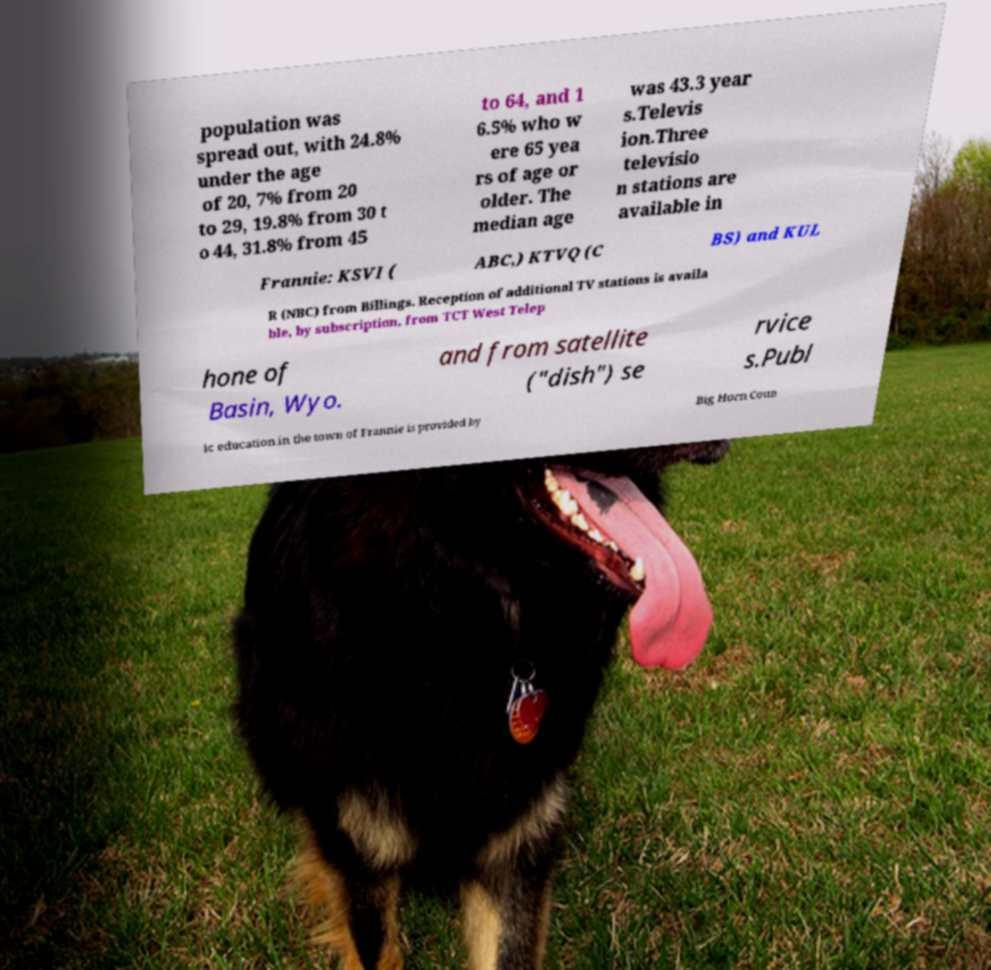There's text embedded in this image that I need extracted. Can you transcribe it verbatim? population was spread out, with 24.8% under the age of 20, 7% from 20 to 29, 19.8% from 30 t o 44, 31.8% from 45 to 64, and 1 6.5% who w ere 65 yea rs of age or older. The median age was 43.3 year s.Televis ion.Three televisio n stations are available in Frannie: KSVI ( ABC,) KTVQ (C BS) and KUL R (NBC) from Billings. Reception of additional TV stations is availa ble, by subscription, from TCT West Telep hone of Basin, Wyo. and from satellite ("dish") se rvice s.Publ ic education in the town of Frannie is provided by Big Horn Coun 